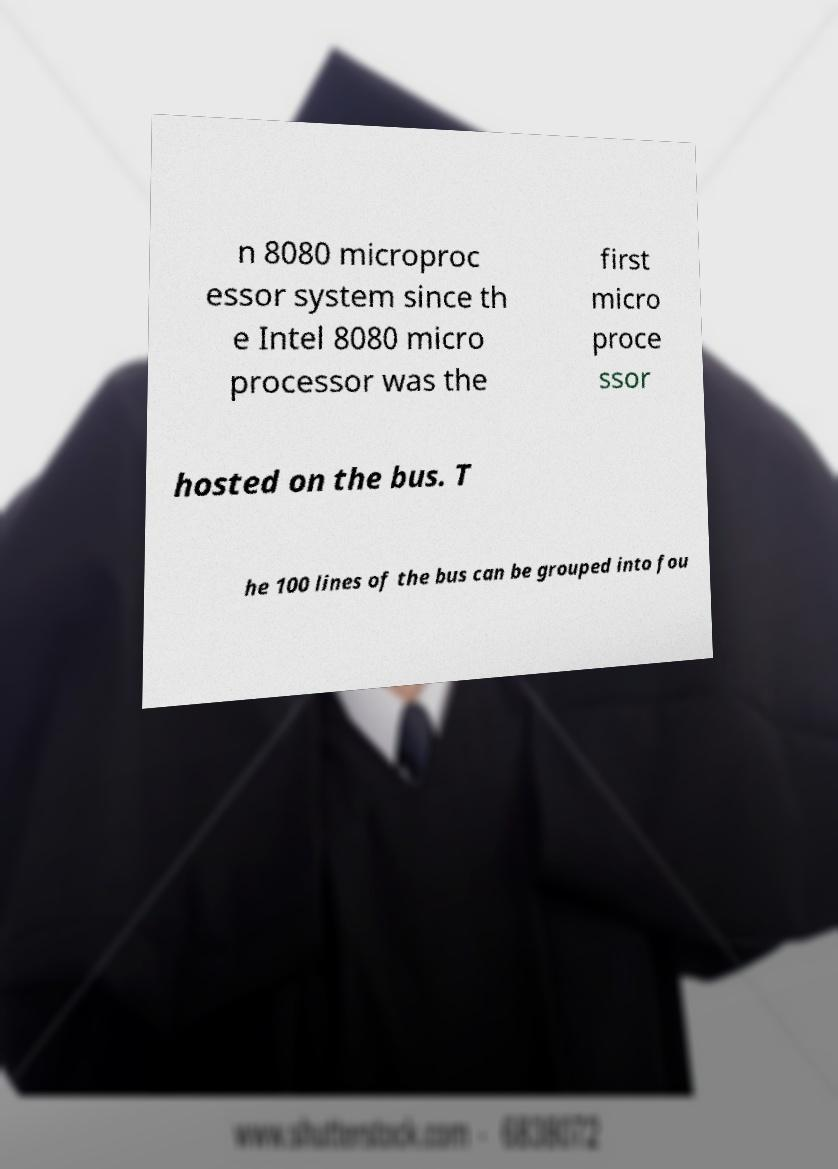Can you accurately transcribe the text from the provided image for me? n 8080 microproc essor system since th e Intel 8080 micro processor was the first micro proce ssor hosted on the bus. T he 100 lines of the bus can be grouped into fou 